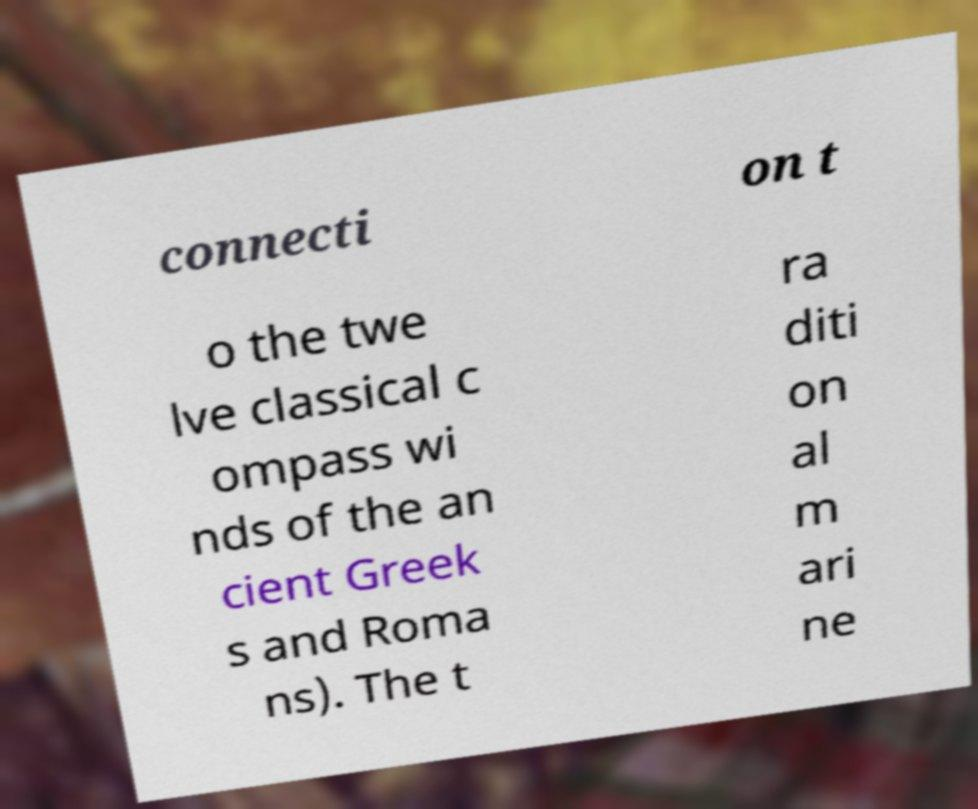For documentation purposes, I need the text within this image transcribed. Could you provide that? connecti on t o the twe lve classical c ompass wi nds of the an cient Greek s and Roma ns). The t ra diti on al m ari ne 